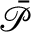Convert formula to latex. <formula><loc_0><loc_0><loc_500><loc_500>\mathcal { \ B a r { P } }</formula> 